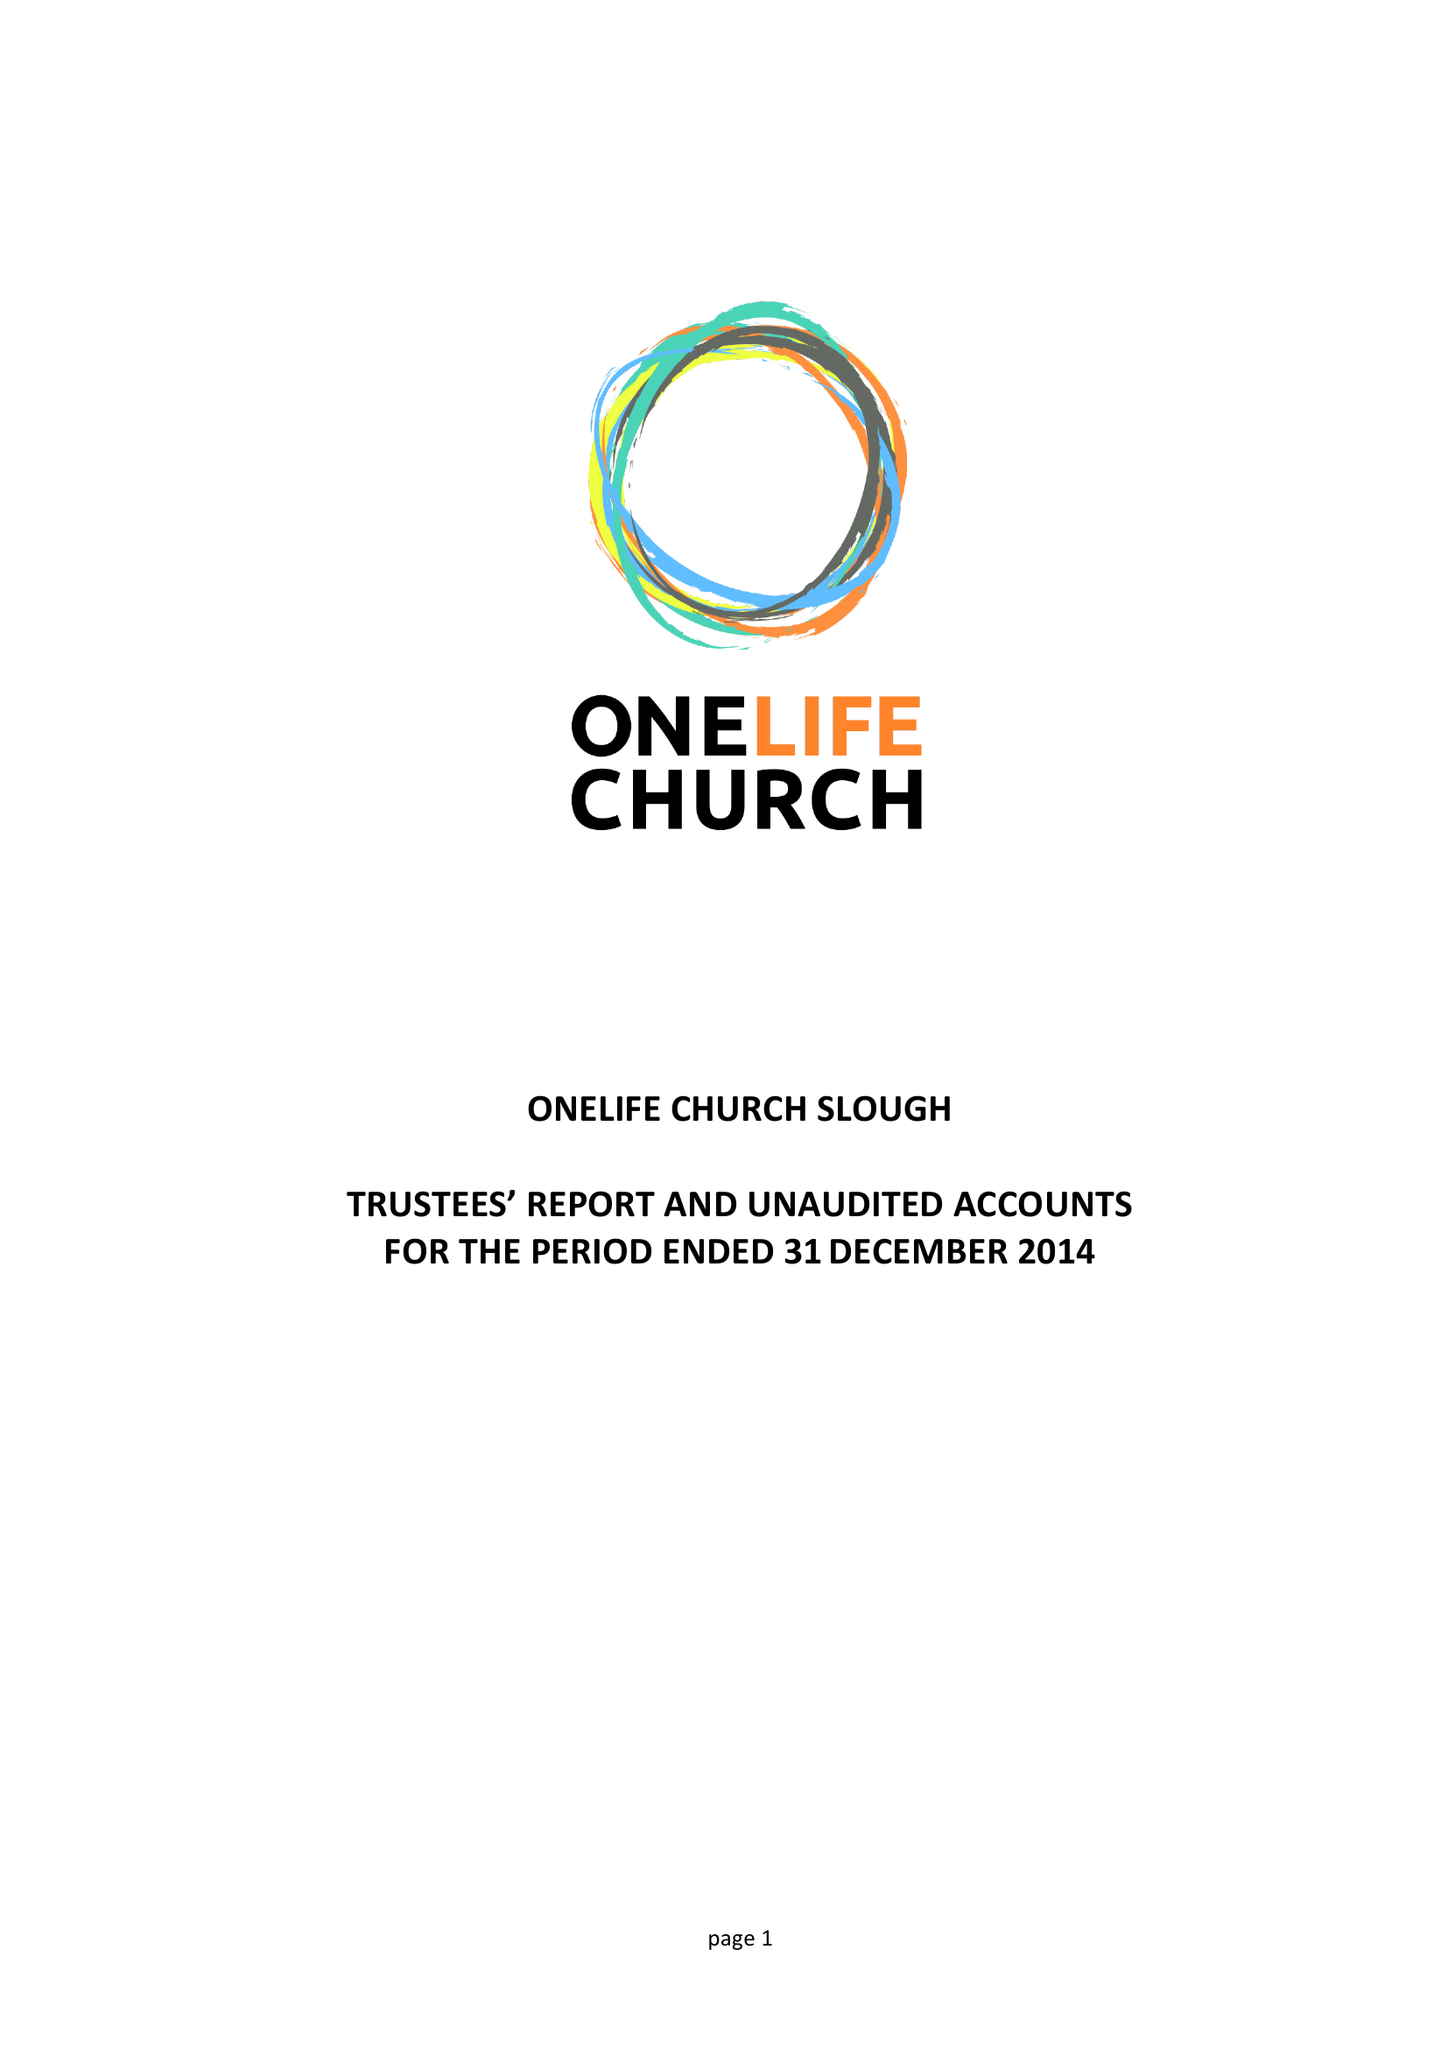What is the value for the address__post_town?
Answer the question using a single word or phrase. SLOUGH 